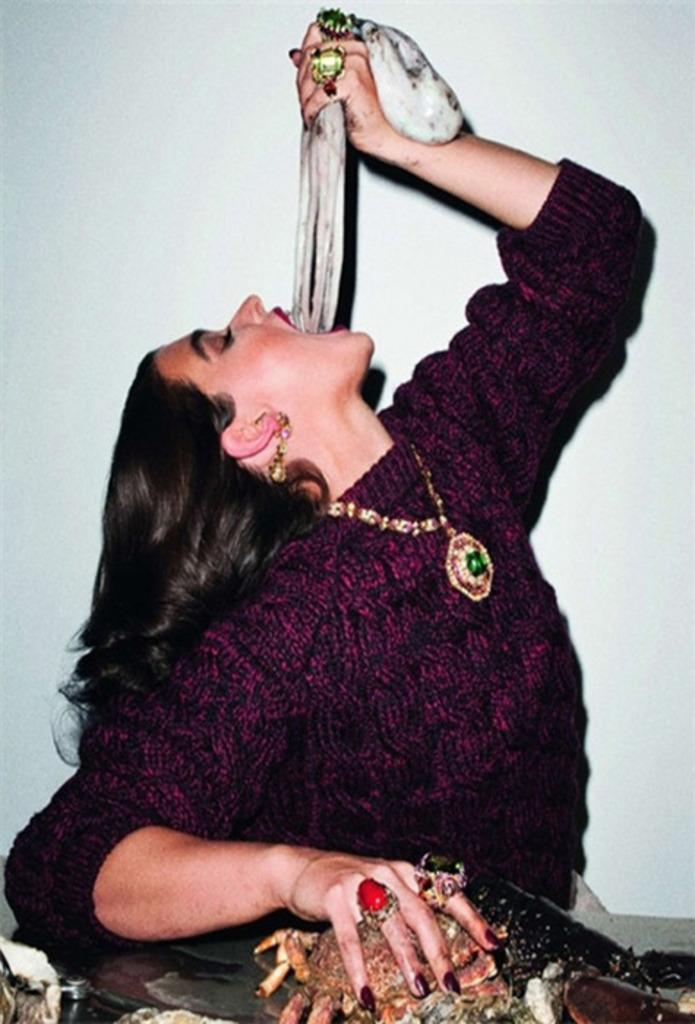What can be seen in the image? There is a person in the image. Can you describe the person's attire? The person is wearing a pink and black color dress. What is the person holding in the image? The person is holding something. What is the background of the image? There is a white background in the image. What else can be seen in the image besides the person? There is something in multi color in the image. What type of space-related alarm can be heard in the image? There is no alarm or sound present in the image, and it does not depict a space-related scene. 